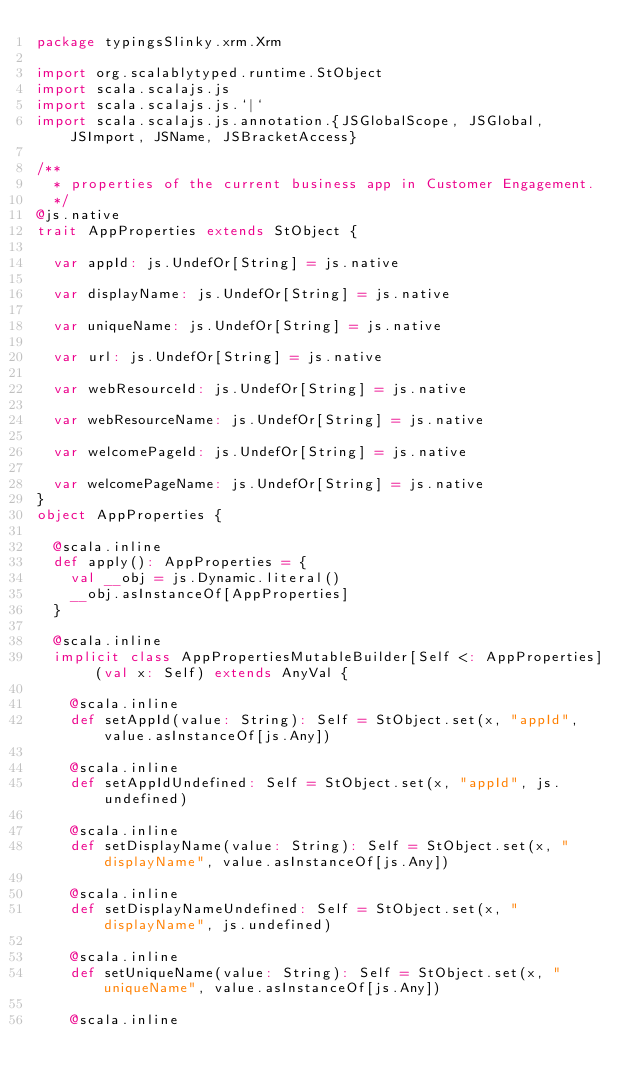<code> <loc_0><loc_0><loc_500><loc_500><_Scala_>package typingsSlinky.xrm.Xrm

import org.scalablytyped.runtime.StObject
import scala.scalajs.js
import scala.scalajs.js.`|`
import scala.scalajs.js.annotation.{JSGlobalScope, JSGlobal, JSImport, JSName, JSBracketAccess}

/**
  * properties of the current business app in Customer Engagement.
  */
@js.native
trait AppProperties extends StObject {
  
  var appId: js.UndefOr[String] = js.native
  
  var displayName: js.UndefOr[String] = js.native
  
  var uniqueName: js.UndefOr[String] = js.native
  
  var url: js.UndefOr[String] = js.native
  
  var webResourceId: js.UndefOr[String] = js.native
  
  var webResourceName: js.UndefOr[String] = js.native
  
  var welcomePageId: js.UndefOr[String] = js.native
  
  var welcomePageName: js.UndefOr[String] = js.native
}
object AppProperties {
  
  @scala.inline
  def apply(): AppProperties = {
    val __obj = js.Dynamic.literal()
    __obj.asInstanceOf[AppProperties]
  }
  
  @scala.inline
  implicit class AppPropertiesMutableBuilder[Self <: AppProperties] (val x: Self) extends AnyVal {
    
    @scala.inline
    def setAppId(value: String): Self = StObject.set(x, "appId", value.asInstanceOf[js.Any])
    
    @scala.inline
    def setAppIdUndefined: Self = StObject.set(x, "appId", js.undefined)
    
    @scala.inline
    def setDisplayName(value: String): Self = StObject.set(x, "displayName", value.asInstanceOf[js.Any])
    
    @scala.inline
    def setDisplayNameUndefined: Self = StObject.set(x, "displayName", js.undefined)
    
    @scala.inline
    def setUniqueName(value: String): Self = StObject.set(x, "uniqueName", value.asInstanceOf[js.Any])
    
    @scala.inline</code> 